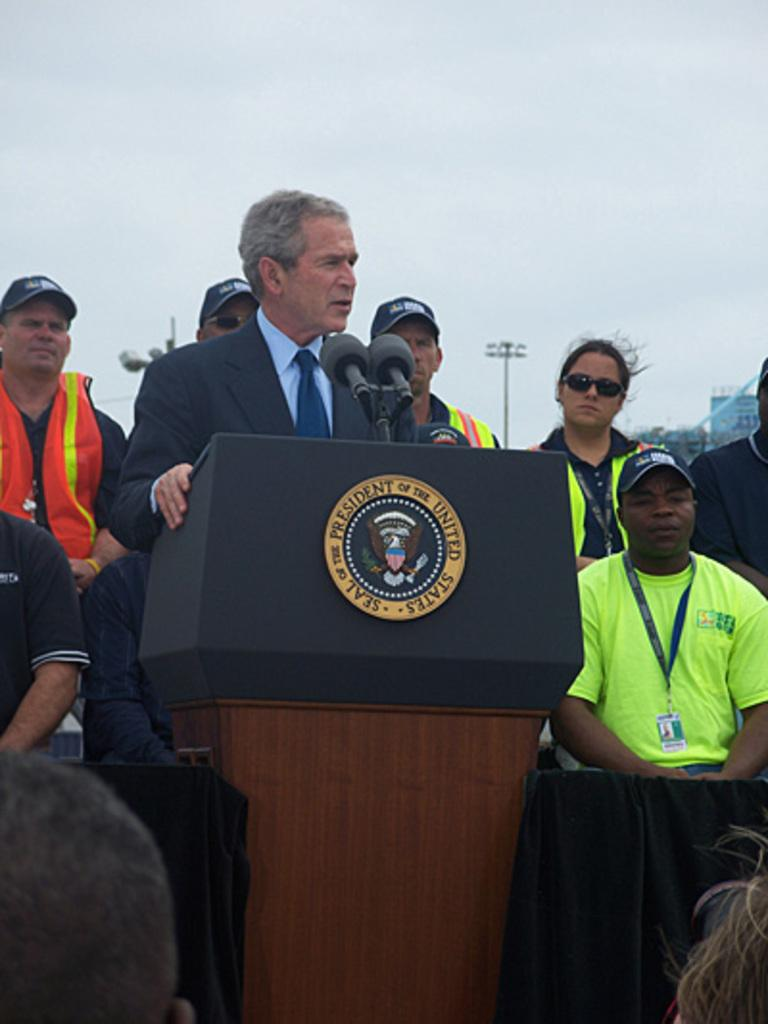What is the person in the image wearing? The person in the image is wearing a suit. Where is the person standing in relation to the desk? The person is standing in front of a desk. What can be seen on the desk? There is a mic on the desk. How many people are visible in the image? There are other people in the image besides the person in the suit. What is the tall, vertical object in the image? There is a pole in the image. What type of muscle can be seen flexing in the image? There is no muscle visible in the image; it is a person standing in front of a desk. 